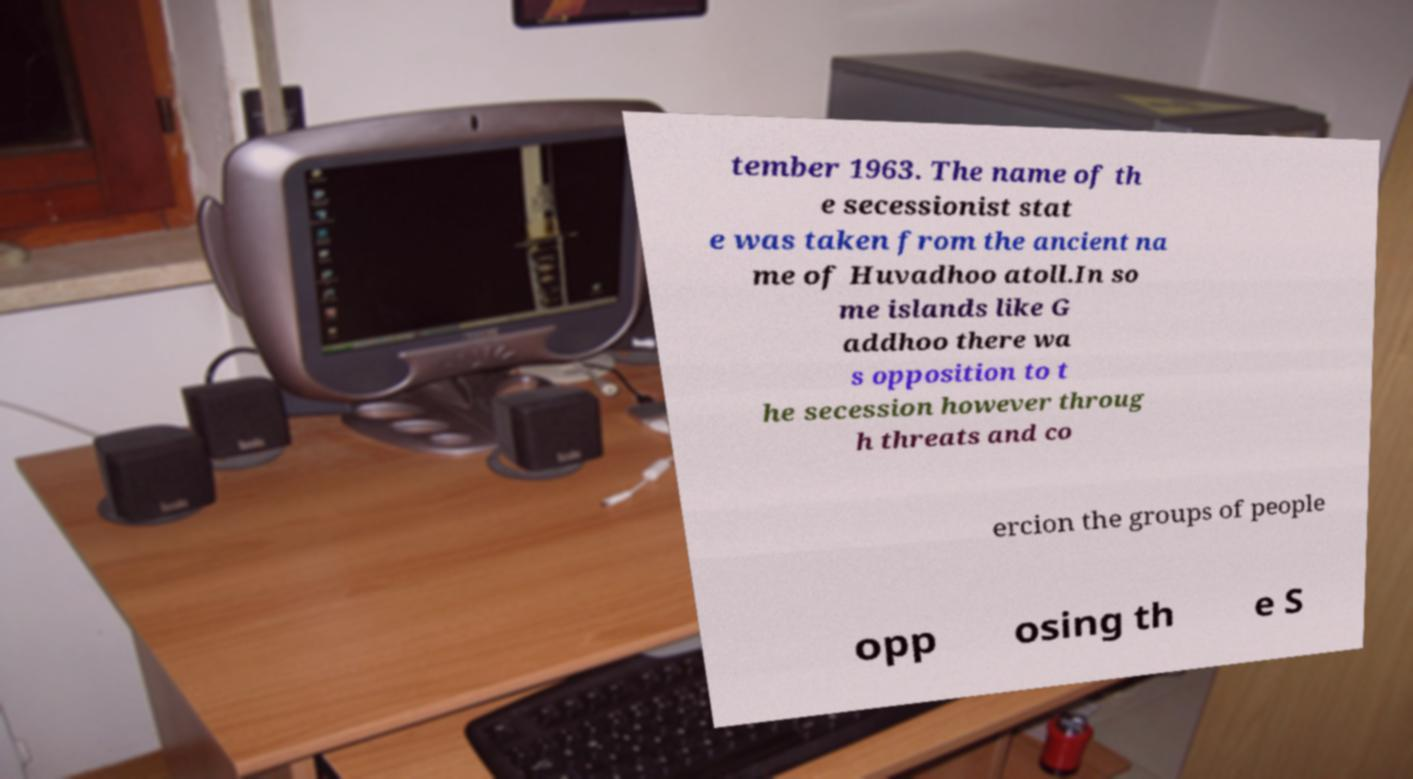Please identify and transcribe the text found in this image. tember 1963. The name of th e secessionist stat e was taken from the ancient na me of Huvadhoo atoll.In so me islands like G addhoo there wa s opposition to t he secession however throug h threats and co ercion the groups of people opp osing th e S 